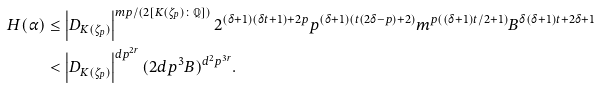Convert formula to latex. <formula><loc_0><loc_0><loc_500><loc_500>H ( \alpha ) & \leq \left | D _ { K ( \zeta _ { p } ) } \right | ^ { m p / ( 2 [ K ( \zeta _ { p } ) \colon \mathbb { Q } ] ) } 2 ^ { ( \delta + 1 ) ( \delta t + 1 ) + 2 p } p ^ { ( \delta + 1 ) ( t ( 2 \delta - p ) + 2 ) } m ^ { p ( ( \delta + 1 ) t / 2 + 1 ) } B ^ { \delta ( \delta + 1 ) t + 2 \delta + 1 } \\ & < \left | D _ { K ( \zeta _ { p } ) } \right | ^ { d p ^ { 2 r } } ( 2 d p ^ { 3 } B ) ^ { d ^ { 2 } p ^ { 3 r } } .</formula> 